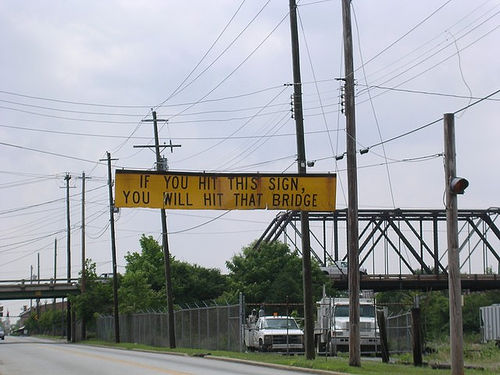Read all the text in this image. IF YOU HIT THIS SIGN BRIDGE THAT HIT WILL YOU 